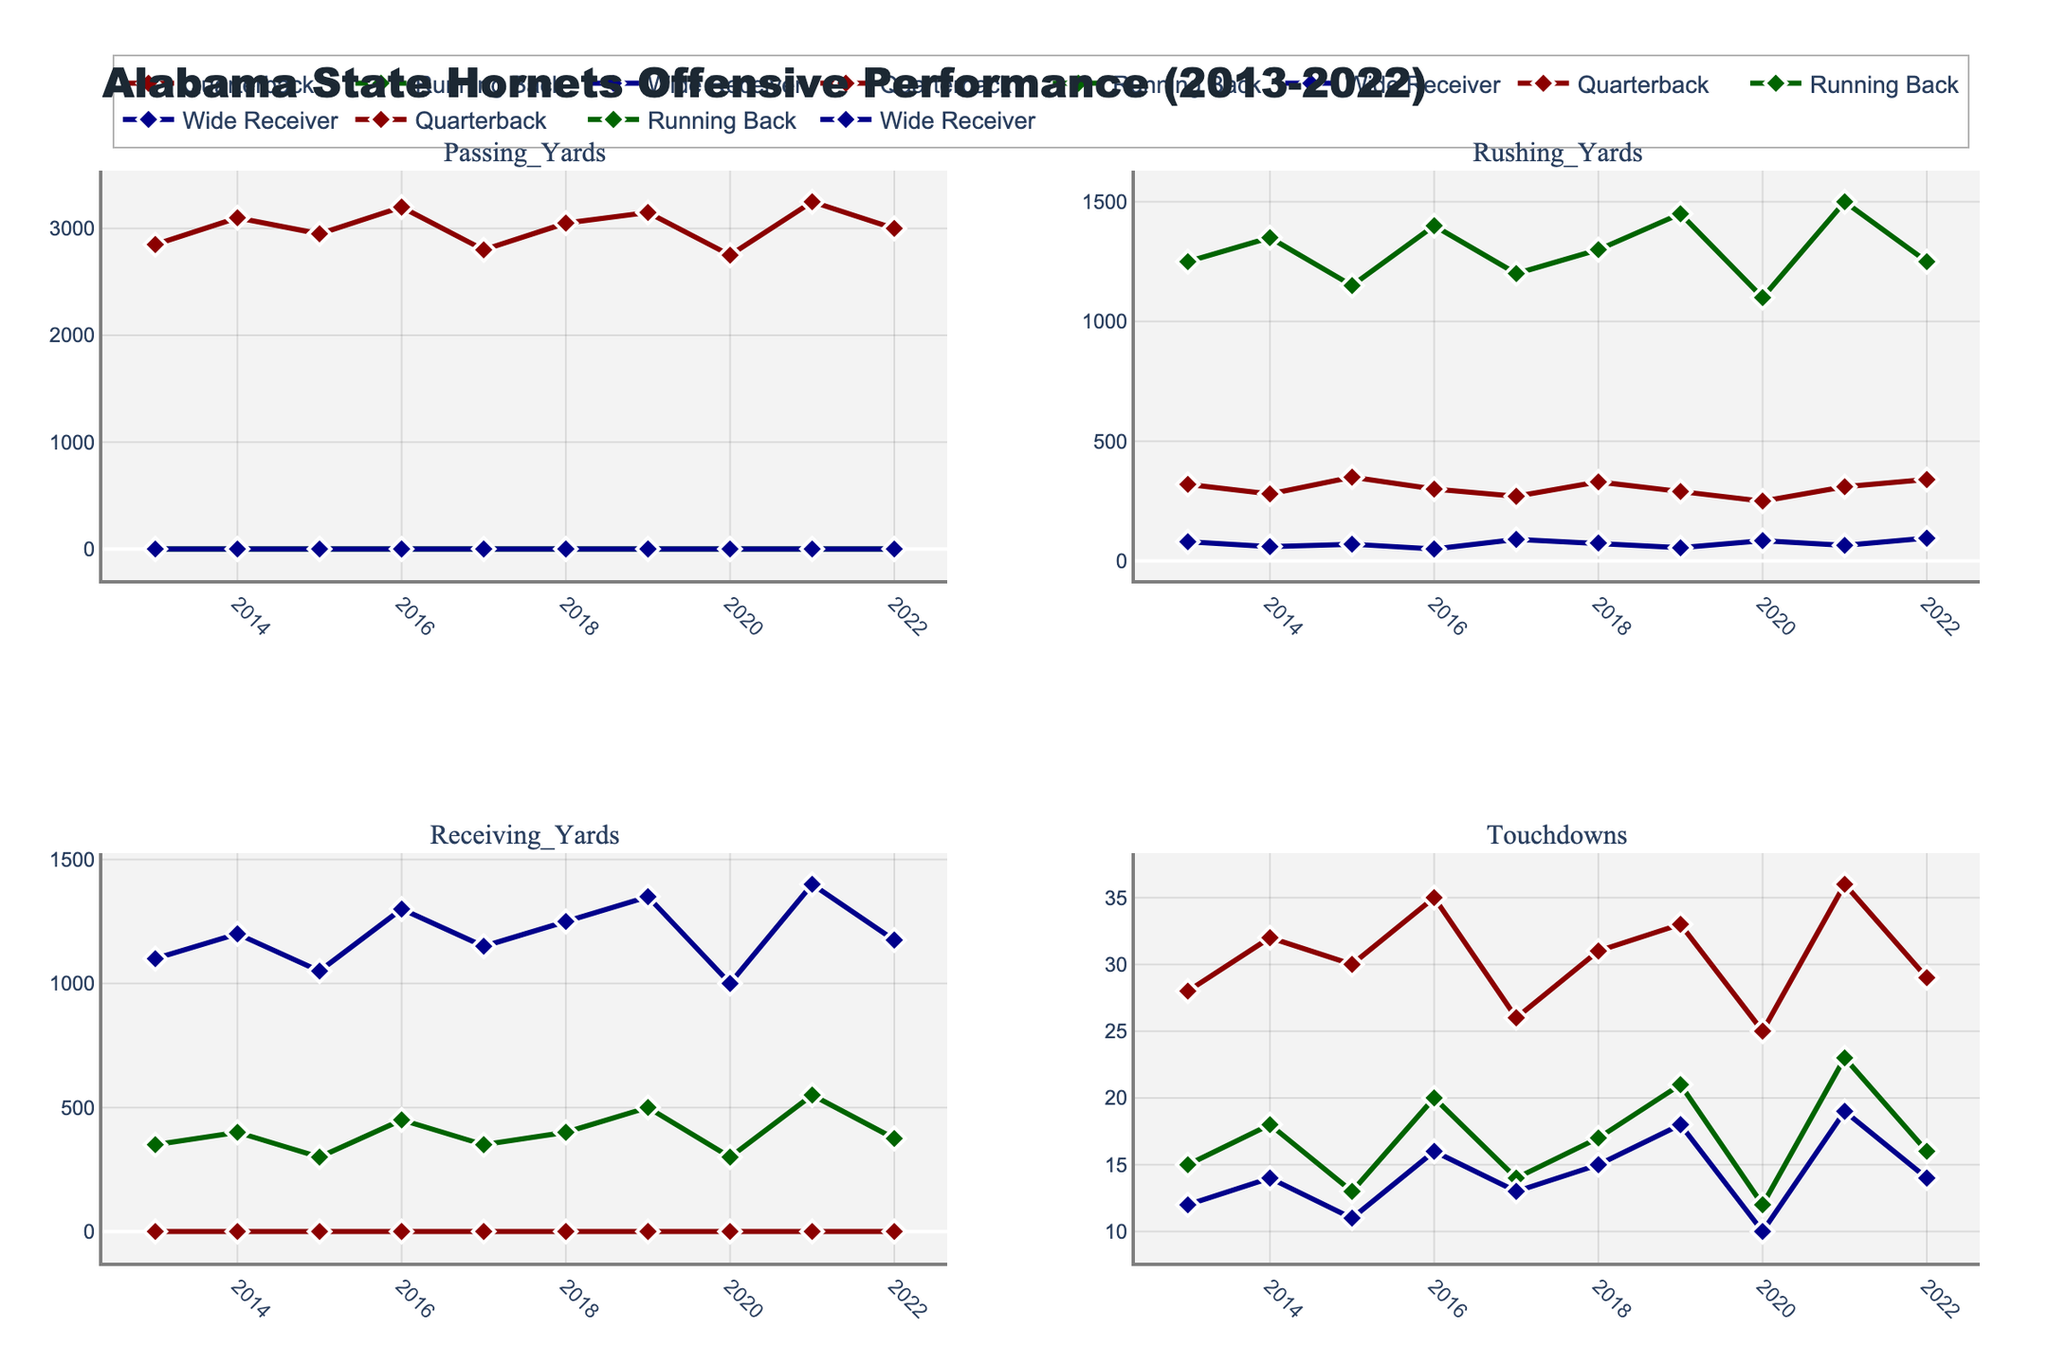What is the title of this figure? The title is written at the top center of the figure. It says "Quality Control Test Results Analysis".
Answer: Quality Control Test Results Analysis Which product category has the highest pass rate? To determine the category with the highest pass rate, look at the bar chart in the top-left subplot. The tallest green bar signifies the highest pass rate, which is for Pharmaceuticals.
Answer: Pharmaceuticals What do the colors green and red represent in the bar chart? In the bar chart, the green bars represent the pass rates, and the red bars represent the fail rates for each product category.
Answer: Pass and Fail rates Which product category has the highest fail rate, and what is the rate? To find the highest fail rate, look at the red bars in the top-left subplot. The tallest red bar corresponds to Automotive Parts, and the y-axis label indicates this rate as 11.7%.
Answer: Automotive Parts, 11.7% What is the average pass rate across all product categories as shown in the pie chart? The pie chart in the top-right subplot shows the overall pass and fail rates. The pass rate is represented by the larger green portion of the pie chart and is numerically labeled. It is 93.64%.
Answer: 93.64% Is there a negative correlation between pass rate and fail rate? Refer to the heatmap in the bottom-right subplot, which shows the correlation matrix. The color scale suggests the strength and direction of correlation. The correlation value between pass rate and fail rate is -1, indicating a perfect negative correlation.
Answer: Yes For which product categories are pass rates clustered around 90%? Look at the scatter plot in the bottom-left subplot. Categories grouped around 90% on the y-axis include Electronics, Consumer Appliances, and Textiles.
Answer: Electronics, Consumer Appliances, Textiles Which product category has a pass rate close to 95% but is not the highest? From the bar chart in the top-left subplot, Aerospace Components have a pass rate close to 95% but are not the highest.
Answer: Aerospace Components How is the distribution of pass rates visually represented in different subplots? The pass rates are visualized using different methods: bar heights in the top-left subplot, pie chart segment size in the top-right subplot, scatter plot point positions in the bottom-left subplot, and color intensity in the heatmap's correlation matrix in the bottom-right subplot.
Answer: Bar heights, pie chart size, scatter plot points, heatmap color intensity Which product category has the closest pass and fail rates? The closest pass and fail rates would be where the green and red bar heights are most similar. This is true for Automotive Parts, where the bars are closest.
Answer: Automotive Parts 